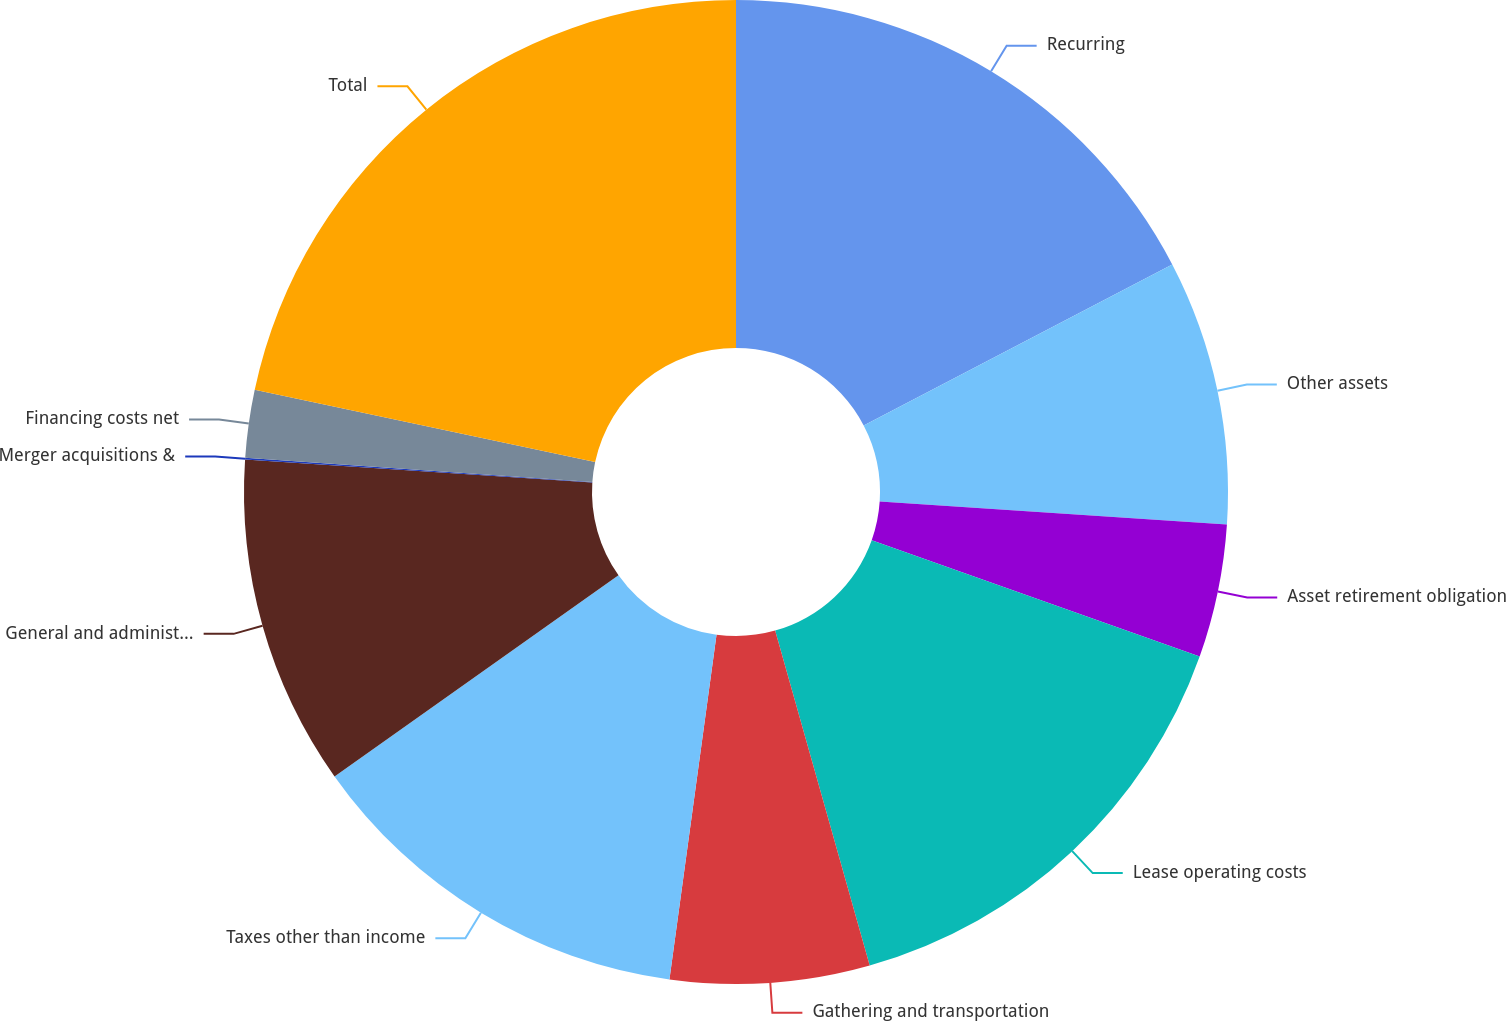<chart> <loc_0><loc_0><loc_500><loc_500><pie_chart><fcel>Recurring<fcel>Other assets<fcel>Asset retirement obligation<fcel>Lease operating costs<fcel>Gathering and transportation<fcel>Taxes other than income<fcel>General and administrative<fcel>Merger acquisitions &<fcel>Financing costs net<fcel>Total<nl><fcel>17.35%<fcel>8.7%<fcel>4.38%<fcel>15.19%<fcel>6.54%<fcel>13.03%<fcel>10.86%<fcel>0.06%<fcel>2.22%<fcel>21.67%<nl></chart> 